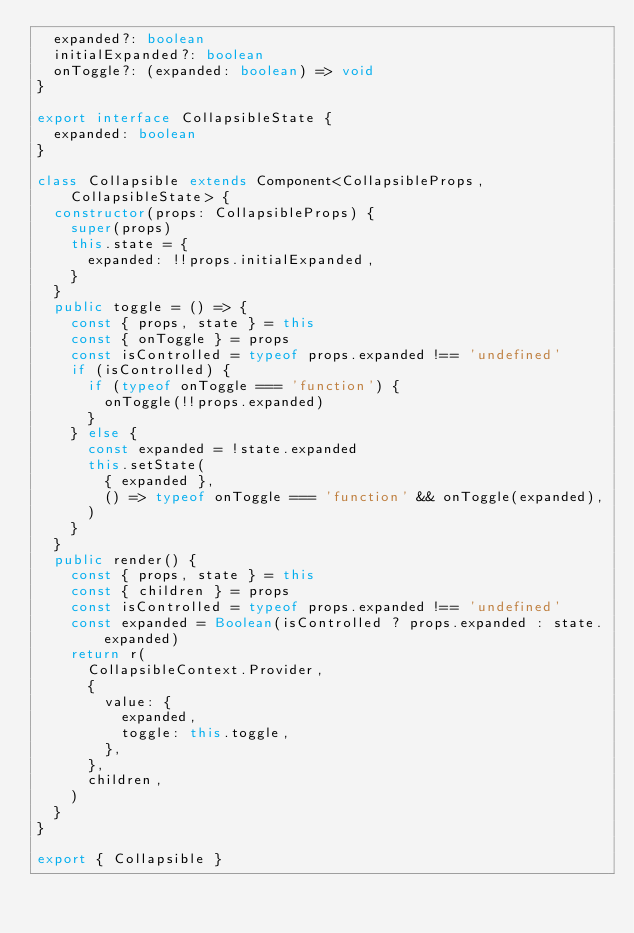<code> <loc_0><loc_0><loc_500><loc_500><_TypeScript_>  expanded?: boolean
  initialExpanded?: boolean
  onToggle?: (expanded: boolean) => void
}

export interface CollapsibleState {
  expanded: boolean
}

class Collapsible extends Component<CollapsibleProps, CollapsibleState> {
  constructor(props: CollapsibleProps) {
    super(props)
    this.state = {
      expanded: !!props.initialExpanded,
    }
  }
  public toggle = () => {
    const { props, state } = this
    const { onToggle } = props
    const isControlled = typeof props.expanded !== 'undefined'
    if (isControlled) {
      if (typeof onToggle === 'function') {
        onToggle(!!props.expanded)
      }
    } else {
      const expanded = !state.expanded
      this.setState(
        { expanded },
        () => typeof onToggle === 'function' && onToggle(expanded),
      )
    }
  }
  public render() {
    const { props, state } = this
    const { children } = props
    const isControlled = typeof props.expanded !== 'undefined'
    const expanded = Boolean(isControlled ? props.expanded : state.expanded)
    return r(
      CollapsibleContext.Provider,
      {
        value: {
          expanded,
          toggle: this.toggle,
        },
      },
      children,
    )
  }
}

export { Collapsible }
</code> 